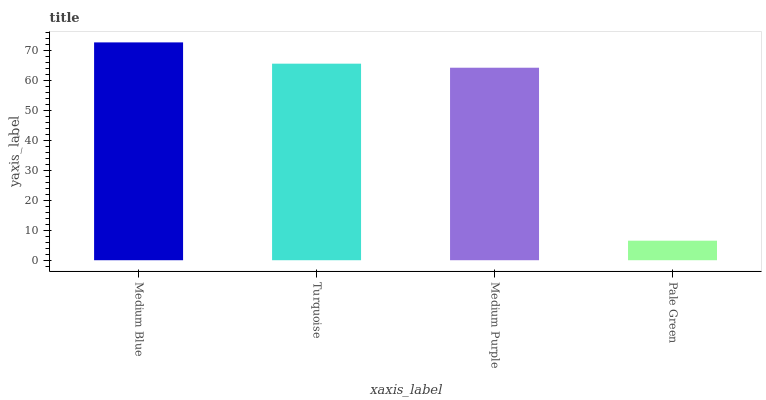Is Pale Green the minimum?
Answer yes or no. Yes. Is Medium Blue the maximum?
Answer yes or no. Yes. Is Turquoise the minimum?
Answer yes or no. No. Is Turquoise the maximum?
Answer yes or no. No. Is Medium Blue greater than Turquoise?
Answer yes or no. Yes. Is Turquoise less than Medium Blue?
Answer yes or no. Yes. Is Turquoise greater than Medium Blue?
Answer yes or no. No. Is Medium Blue less than Turquoise?
Answer yes or no. No. Is Turquoise the high median?
Answer yes or no. Yes. Is Medium Purple the low median?
Answer yes or no. Yes. Is Medium Blue the high median?
Answer yes or no. No. Is Pale Green the low median?
Answer yes or no. No. 